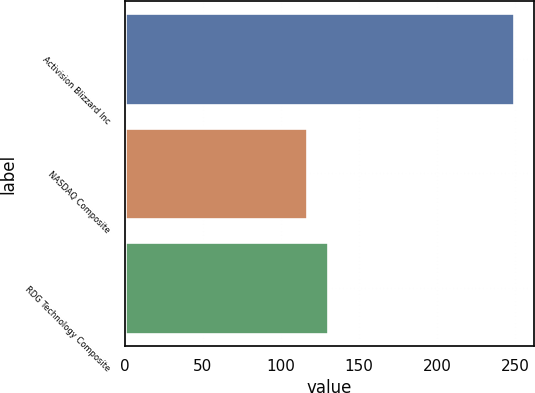Convert chart to OTSL. <chart><loc_0><loc_0><loc_500><loc_500><bar_chart><fcel>Activision Blizzard Inc<fcel>NASDAQ Composite<fcel>RDG Technology Composite<nl><fcel>249.7<fcel>116.61<fcel>129.92<nl></chart> 